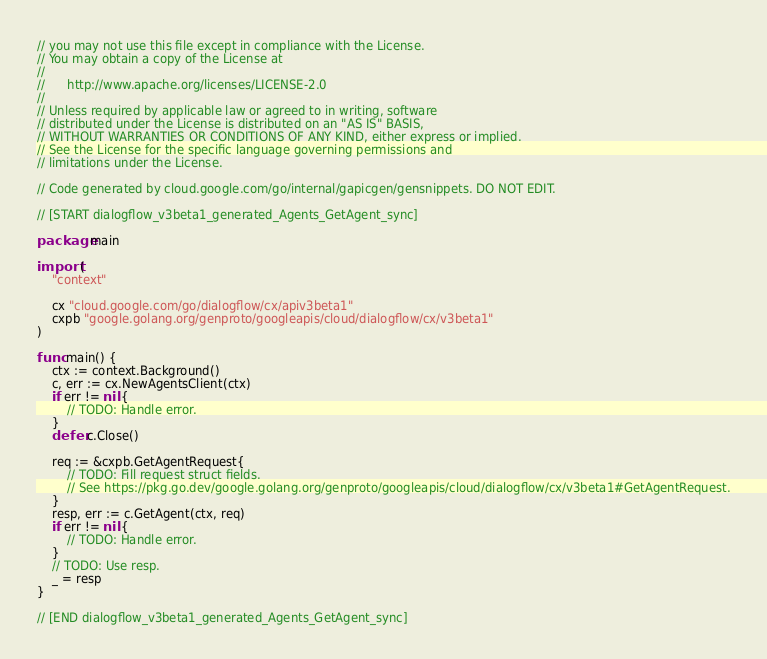Convert code to text. <code><loc_0><loc_0><loc_500><loc_500><_Go_>// you may not use this file except in compliance with the License.
// You may obtain a copy of the License at
//
//      http://www.apache.org/licenses/LICENSE-2.0
//
// Unless required by applicable law or agreed to in writing, software
// distributed under the License is distributed on an "AS IS" BASIS,
// WITHOUT WARRANTIES OR CONDITIONS OF ANY KIND, either express or implied.
// See the License for the specific language governing permissions and
// limitations under the License.

// Code generated by cloud.google.com/go/internal/gapicgen/gensnippets. DO NOT EDIT.

// [START dialogflow_v3beta1_generated_Agents_GetAgent_sync]

package main

import (
	"context"

	cx "cloud.google.com/go/dialogflow/cx/apiv3beta1"
	cxpb "google.golang.org/genproto/googleapis/cloud/dialogflow/cx/v3beta1"
)

func main() {
	ctx := context.Background()
	c, err := cx.NewAgentsClient(ctx)
	if err != nil {
		// TODO: Handle error.
	}
	defer c.Close()

	req := &cxpb.GetAgentRequest{
		// TODO: Fill request struct fields.
		// See https://pkg.go.dev/google.golang.org/genproto/googleapis/cloud/dialogflow/cx/v3beta1#GetAgentRequest.
	}
	resp, err := c.GetAgent(ctx, req)
	if err != nil {
		// TODO: Handle error.
	}
	// TODO: Use resp.
	_ = resp
}

// [END dialogflow_v3beta1_generated_Agents_GetAgent_sync]
</code> 